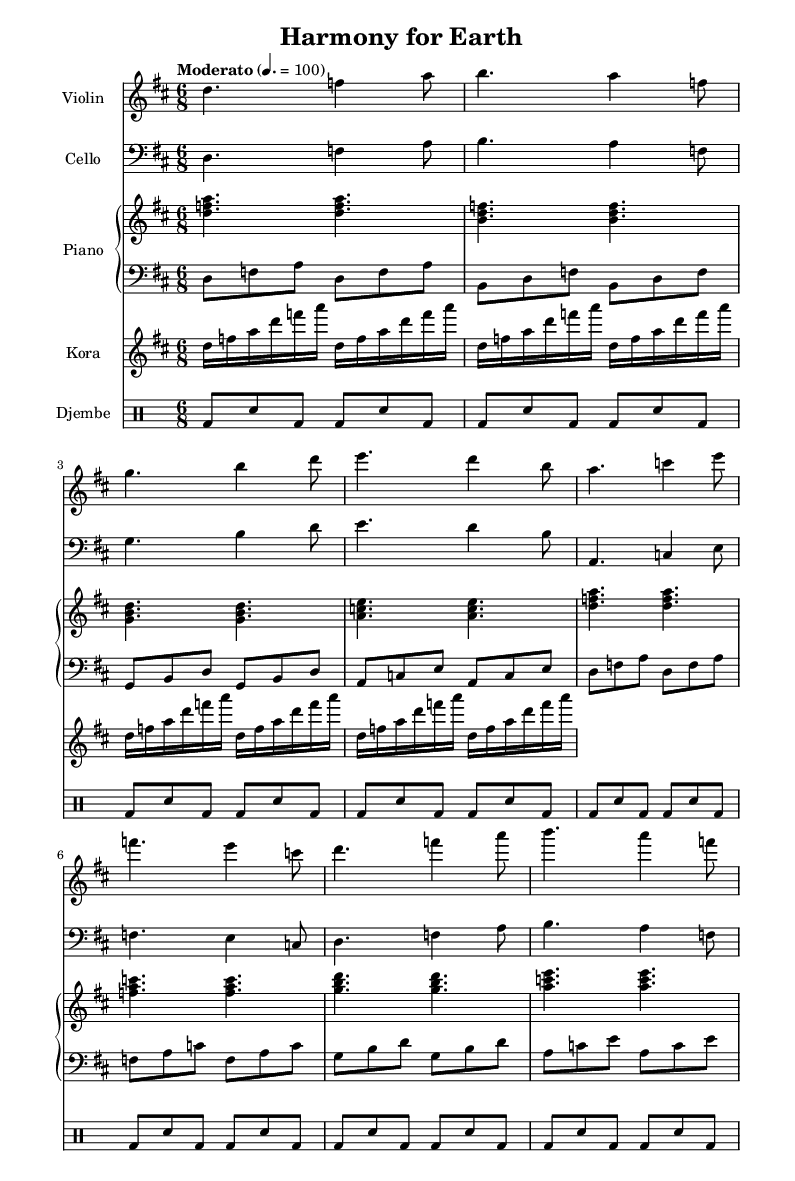What is the key signature of this music? The key signature shows two sharps, which indicates the key of D major.
Answer: D major What is the time signature of this music? The time signature is indicated by the fraction at the beginning of the score, which is 6/8, showing it has six eighth notes per measure.
Answer: 6/8 What is the tempo marking of this piece? The tempo marking is "Moderato," which is indicated above the staff, usually associated with a moderate speed.
Answer: Moderato Which instrument plays the highest pitch in the score? By comparing the ranges of each instrument's music line, the violin, at its higher range, plays the highest pitch notes in this score.
Answer: Violin How many measures are there in the violin part? By counting the segments broken by the bar lines in the violin's music, there are eight measures in total.
Answer: Eight What rhythmic pattern does the djembe follow? The djembe part has a repeating rhythmic pattern, characterized primarily by the beat of a bass drum followed by snare hits, which is structured into eight repetitions.
Answer: Bass-snare How does the fusion of genres appear in this sheet music? The fusion is demonstrated through the integration of African rhythms (djembe and kora) with Western classical elements (violin, cello, and piano), blending both styles into a cohesive composition.
Answer: Fusion of African and Western classical elements 